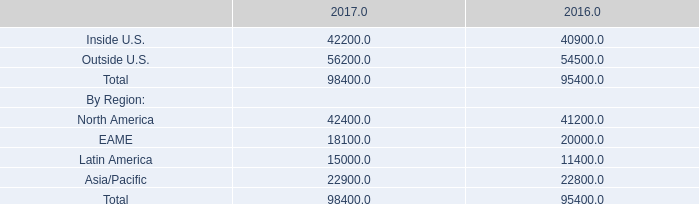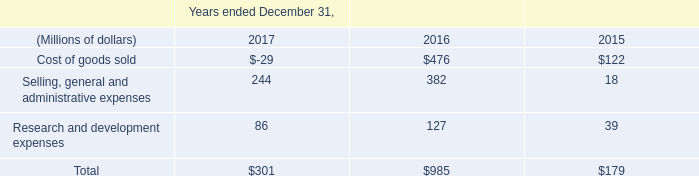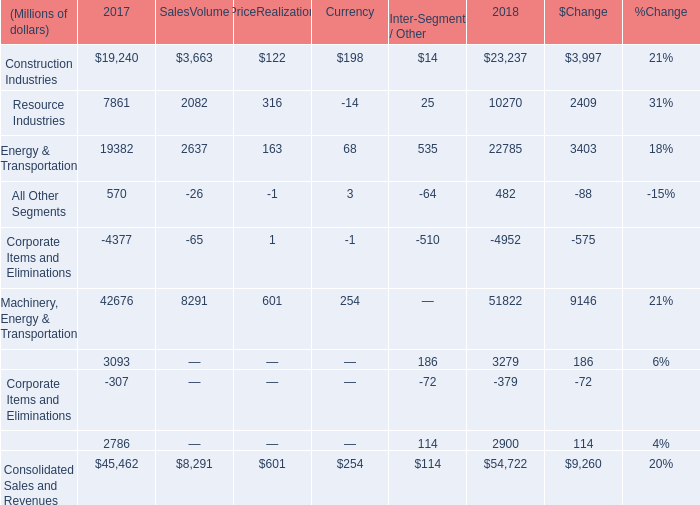What's the average of Outside U.S. of 2016, and Construction Industries of 2018 ? 
Computations: ((54500.0 + 23237.0) / 2)
Answer: 38868.5. 